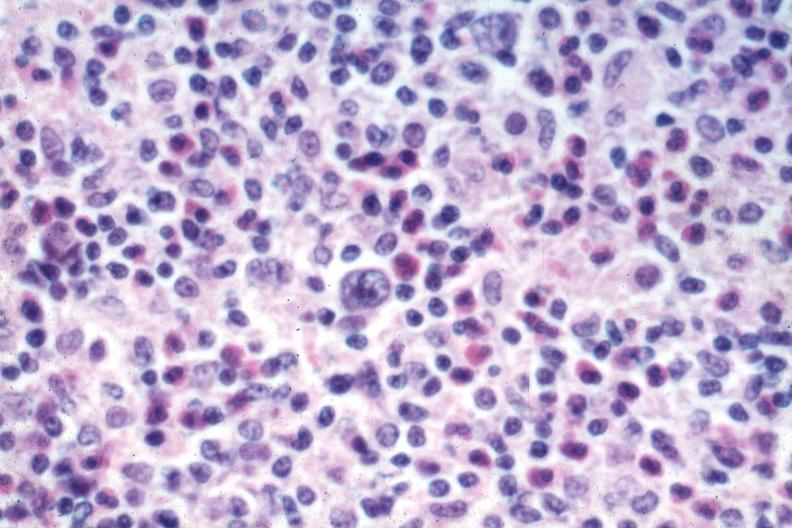what does this image show?
Answer the question using a single word or phrase. Typical with reed sternberg cell source 